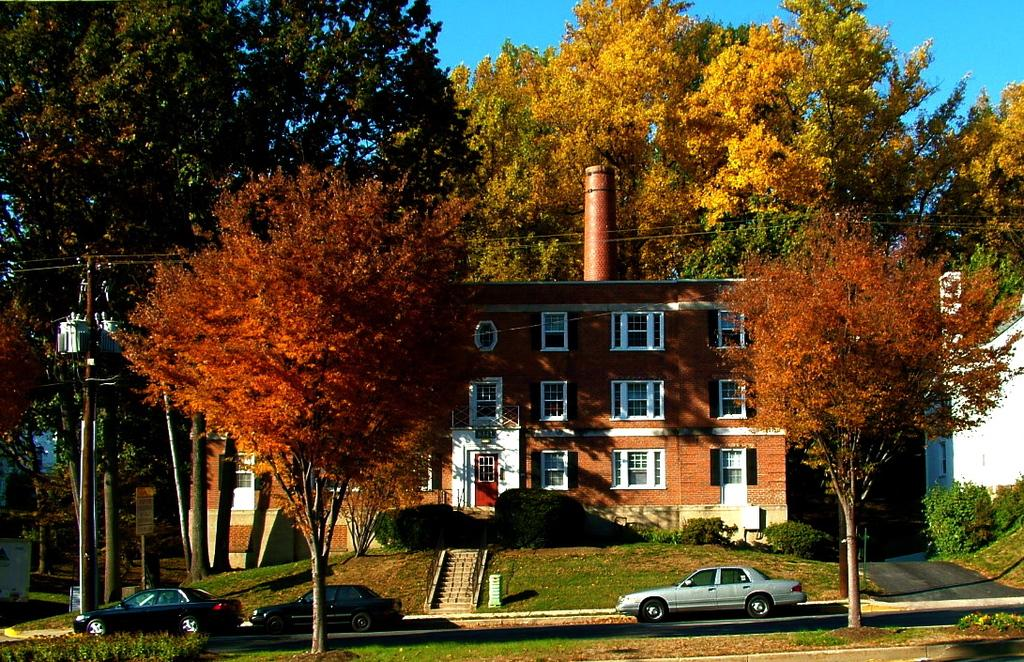What can be seen in the foreground of the image? There are trees and vehicles moving on the road in the foreground of the image. What type of structures are visible in the image? There are buildings visible in the image. What additional elements can be observed in the image? Cables and poles are present in the image. What is visible in the background of the image? The sky is visible in the image. What type of food is being prepared in the image? There is no food preparation visible in the image. What type of corn is growing in the image? There is no corn present in the image. 